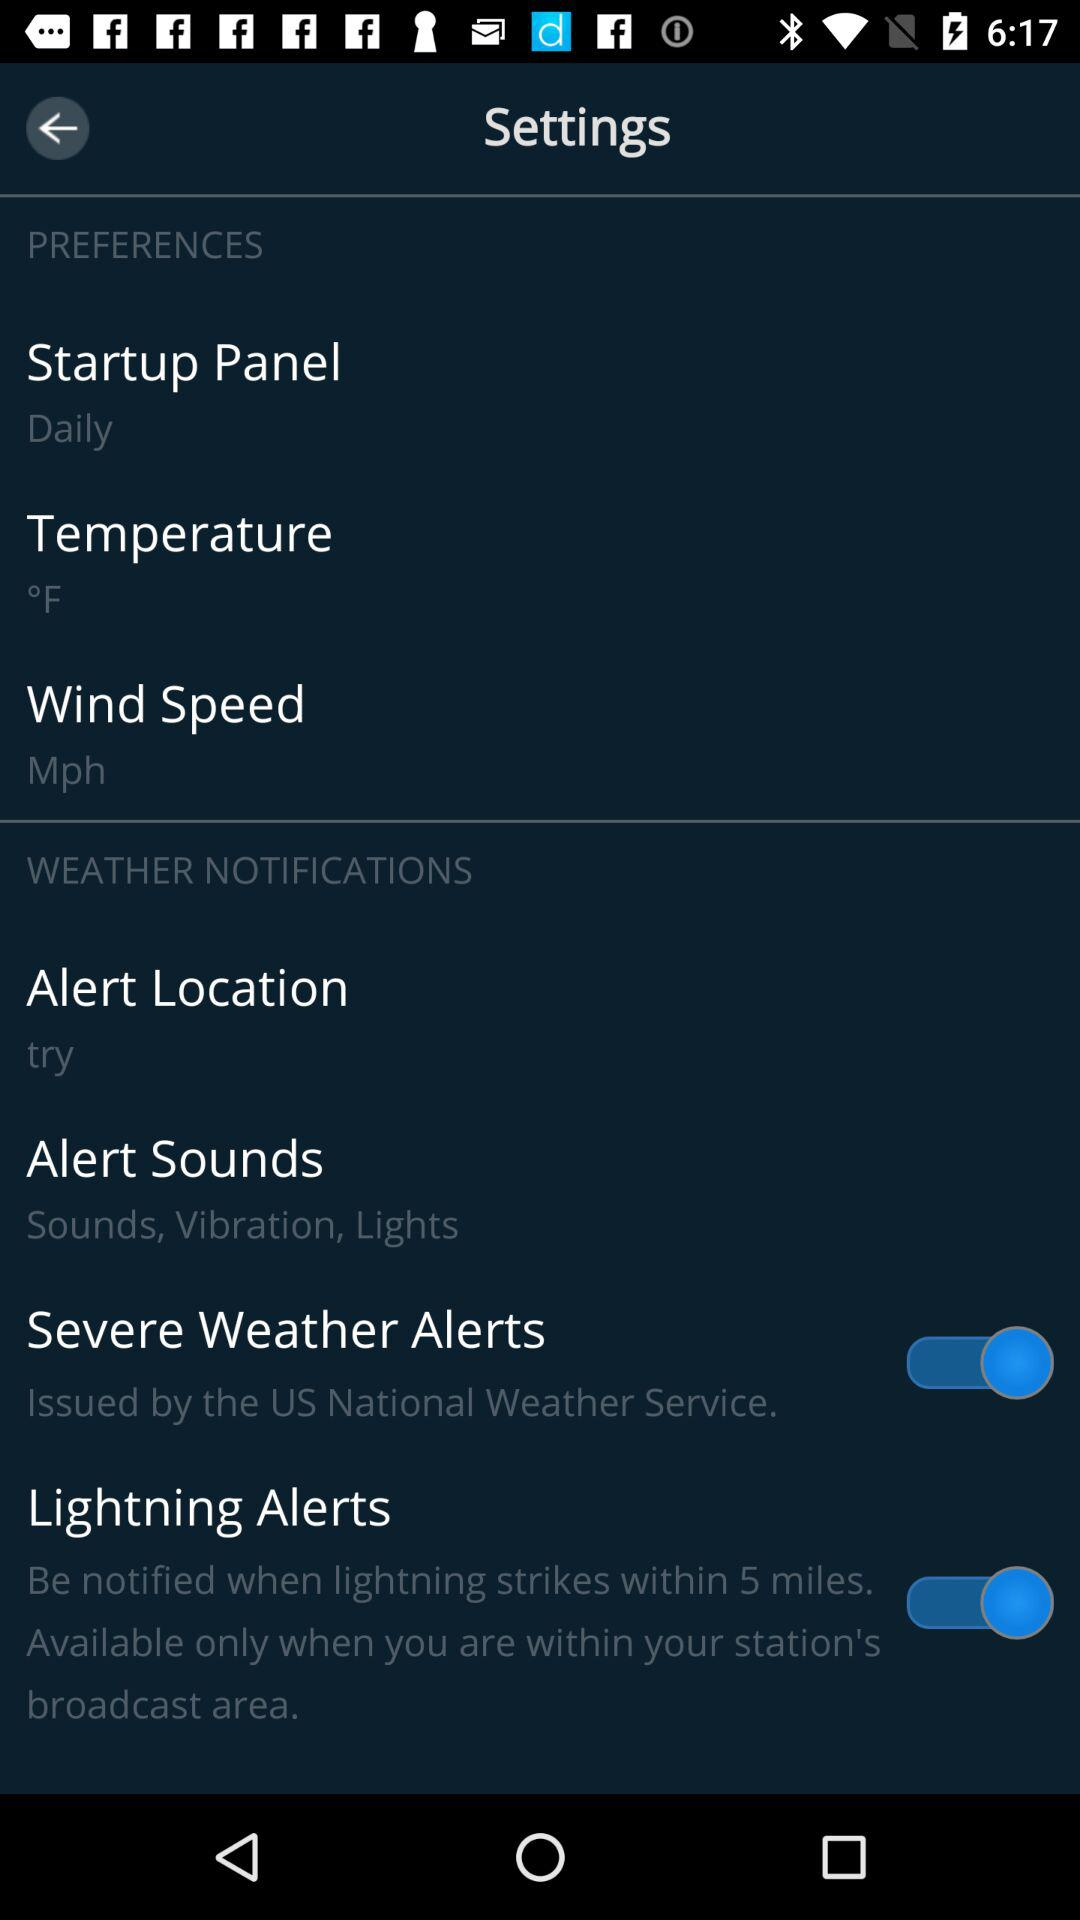How many of the items in the Weather Notifications section have a switch?
Answer the question using a single word or phrase. 2 